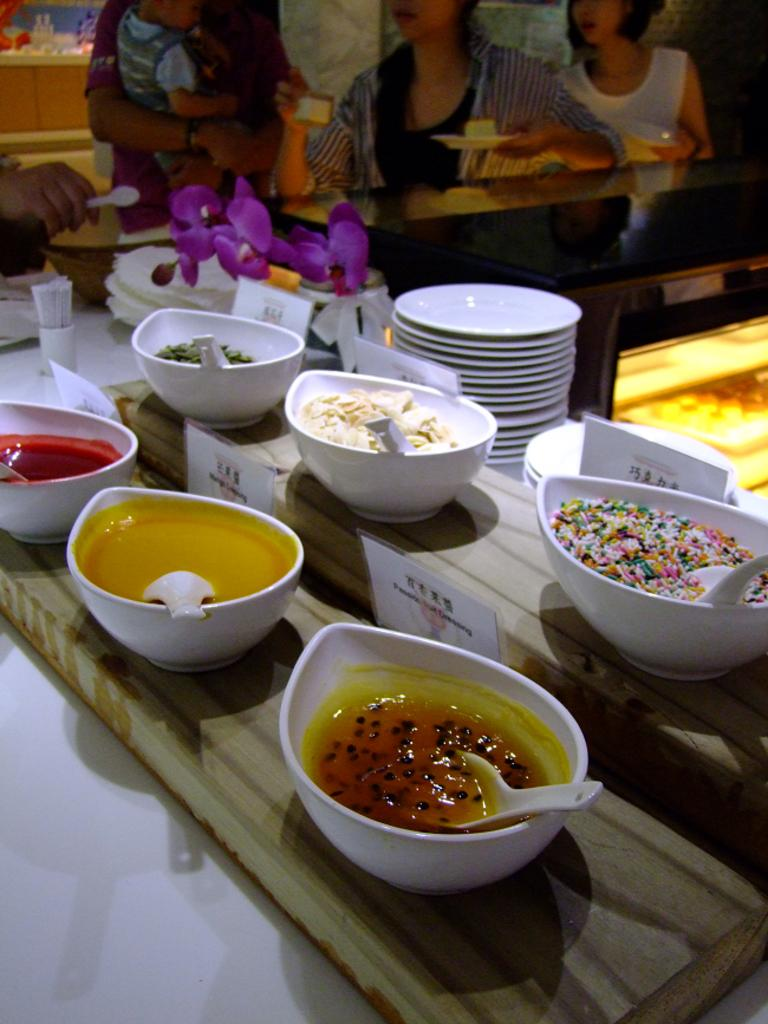What piece of furniture is present in the image? There is a table in the image. What items can be seen on the table? There are plates, bowls, spatulas, napkins, decorations, and dishes on the table. What might be used for cleaning or wiping in the image? Napkins are present on the table for cleaning or wiping. What type of utensils are visible on the table? Spatulas are visible on the table. Are there any decorative elements on the table? Yes, there are decorations on the table. Can you describe the background of the image? There are people in the background of the image. What type of hook can be seen hanging from the ceiling in the image? There is no hook visible in the image; it only features a table with various items and people in the background. 